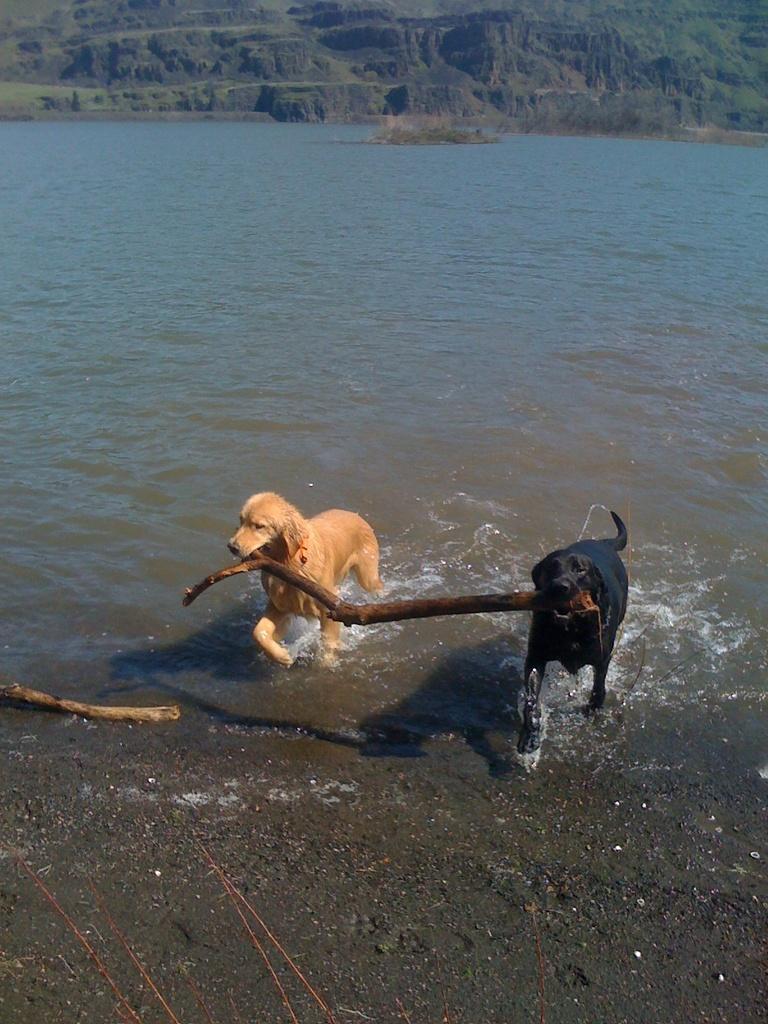How would you summarize this image in a sentence or two? In this image two dogs are holding a stick with their mouth. Dogs are in water. Bottom of image there is land having a stick on it. Top of the image there is hill. 